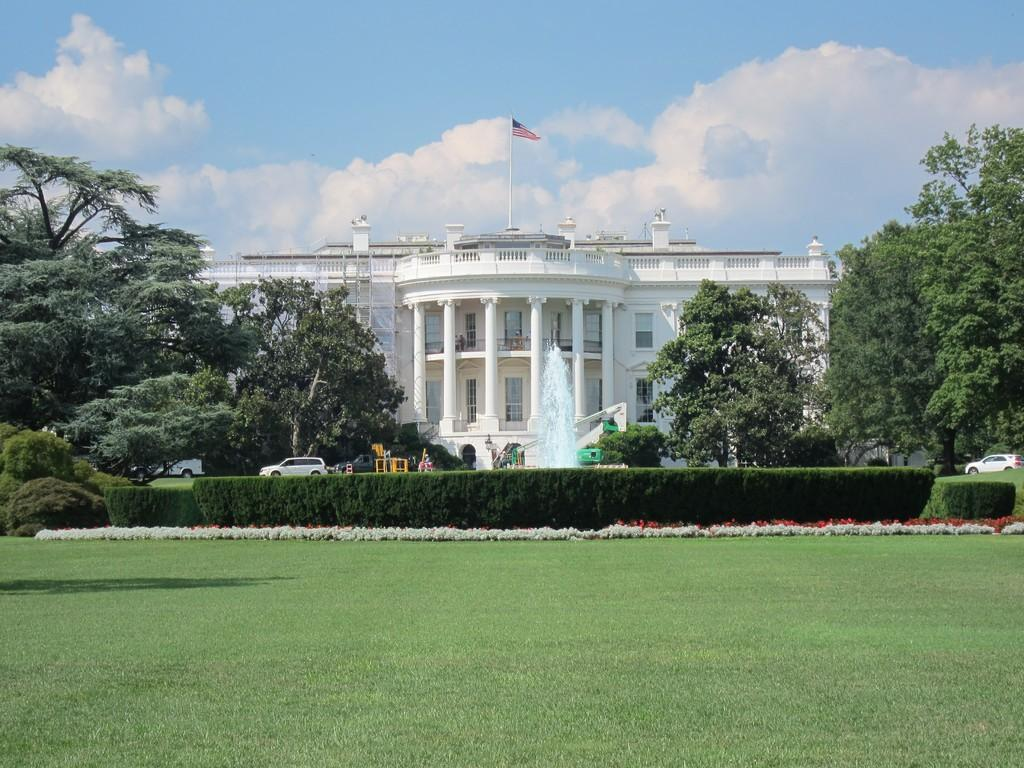What type of natural environment is visible in the image? There is grass and trees visible in the image, indicating a natural environment. What man-made structures can be seen in the image? There are vehicles, a building with windows, and a flag visible in the image. Is there any water visible in the image? Yes, there is water visible in the image. What can be seen in the background of the image? The sky with clouds is visible in the background of the image. What type of work is being done by the seashore in the image? There is no seashore present in the image, and therefore no work being done there. Can you hear the thunder in the image? There is no sound present in the image, so it is impossible to hear thunder. 